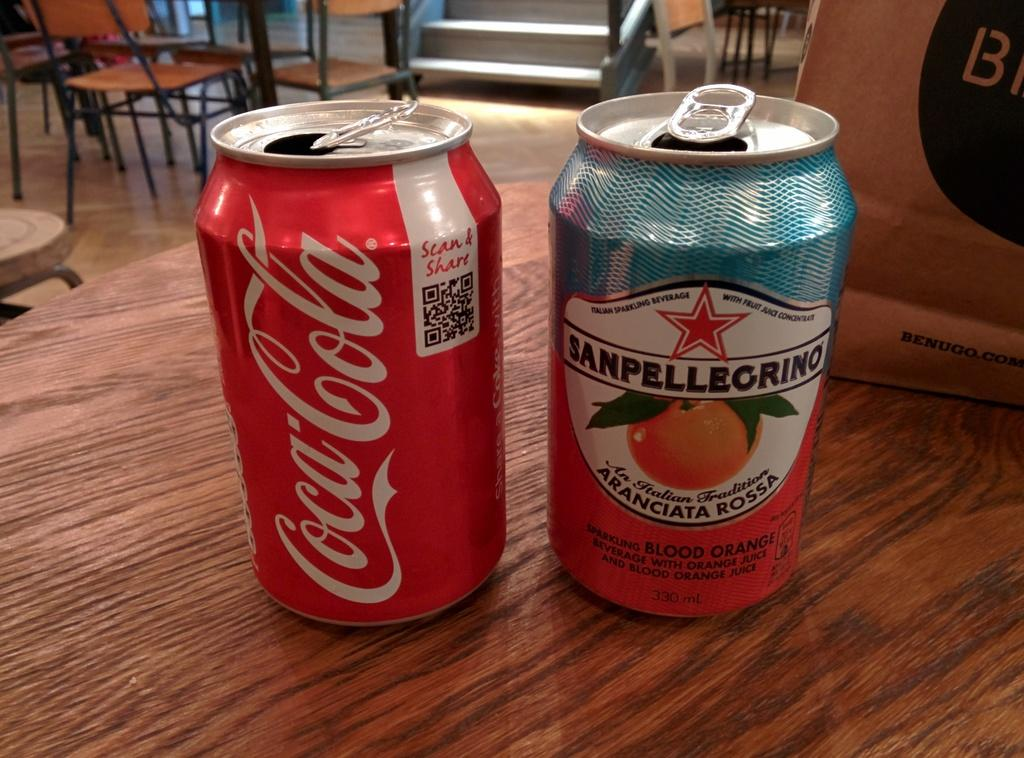<image>
Create a compact narrative representing the image presented. Two cans of soda with one Coca Cola 